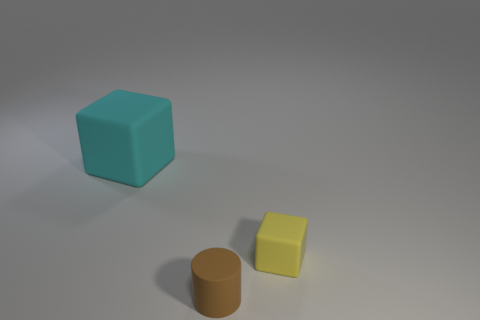There is a rubber cube in front of the large thing; are there any cyan rubber things to the right of it?
Ensure brevity in your answer.  No. Do the brown thing and the object that is left of the small brown cylinder have the same size?
Give a very brief answer. No. Are there any tiny things that are on the left side of the cube in front of the rubber block to the left of the yellow thing?
Ensure brevity in your answer.  Yes. There is a cube that is on the left side of the small yellow thing; what is it made of?
Give a very brief answer. Rubber. Do the yellow rubber block and the cyan matte cube have the same size?
Offer a very short reply. No. There is a thing that is in front of the big cyan thing and behind the brown cylinder; what is its color?
Your answer should be compact. Yellow. What is the shape of the small yellow thing that is made of the same material as the big object?
Offer a terse response. Cube. How many cubes are on the left side of the tiny yellow rubber thing and right of the cyan matte cube?
Your answer should be compact. 0. There is a tiny brown cylinder; are there any cylinders on the left side of it?
Offer a terse response. No. Is the shape of the tiny thing that is in front of the yellow thing the same as the small thing that is behind the cylinder?
Keep it short and to the point. No. 